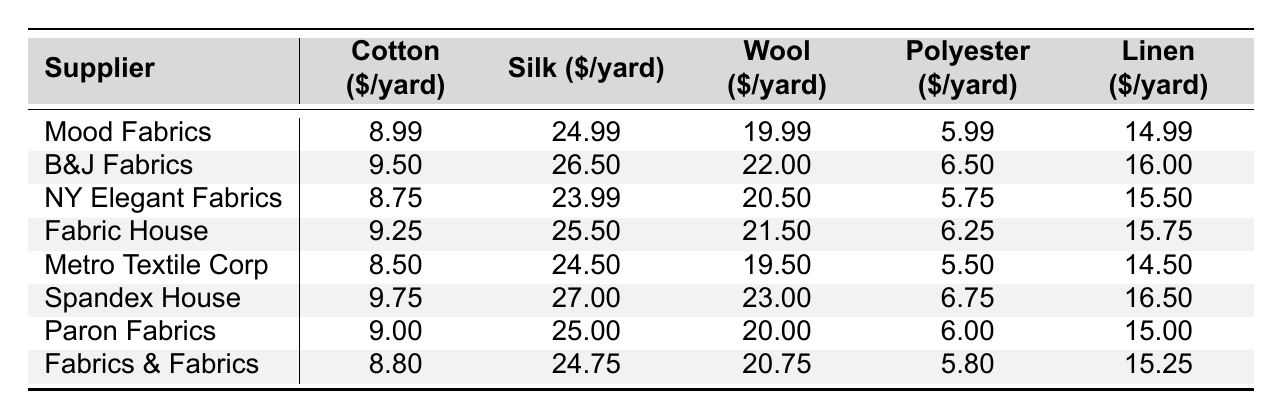What is the price of silk per yard at Mood Fabrics? According to the table, the price of silk at Mood Fabrics is directly listed as 24.99 dollars per yard.
Answer: 24.99 Which supplier offers the cheapest cotton? The table shows that the cotton price is lowest at Metro Textile Corp, where it costs 8.50 dollars per yard.
Answer: 8.50 What is the price difference between the silk at B&J Fabrics and NY Elegant Fabrics? The silk price at B&J Fabrics is 26.50 dollars and at NY Elegant Fabrics is 23.99 dollars. The difference is calculated as 26.50 - 23.99 = 2.51 dollars.
Answer: 2.51 Which supplier has the most expensive wool? Look at the wool prices across all suppliers, and you'll find that Spandex House offers the most expensive wool at 23.00 dollars per yard.
Answer: Spandex House What is the average price of polyester across all suppliers? To find the average, sum the polyester prices: (5.99 + 6.50 + 5.75 + 6.25 + 5.50 + 6.75 + 6.00 + 5.80) = 48.54 dollars. Then, divide by the number of suppliers (8) which gives 48.54 / 8 = 6.0675 dollars.
Answer: 6.07 Is the price of linen at Fabric House higher than at Mood Fabrics? Check the linen prices: Fabric House charges 15.75 dollars and Mood Fabrics charges 14.99 dollars. Since 15.75 is greater than 14.99, the answer is yes.
Answer: Yes If I want to buy all five types of fabric from the cheapest supplier, how much would it cost in total? First, identify the cheapest prices: Cotton (Metro Textile Corp - 8.50), Silk (NY Elegant Fabrics - 23.99), Wool (Metro Textile Corp - 19.50), Polyester (Metro Textile Corp - 5.50), Linen (Metro Textile Corp - 14.50). Add these values: 8.50 + 23.99 + 19.50 + 5.50 + 14.50 = 71.99 dollars.
Answer: 71.99 How much more expensive is silk at Spandex House compared to NY Elegant Fabrics? Silk at Spandex House costs 27.00 dollars and at NY Elegant Fabrics, it costs 23.99 dollars. The difference is 27.00 - 23.99 = 3.01 dollars.
Answer: 3.01 Which supplier has the lowest total cost for buying one yard of each fabric type? Calculate the total costs: Mood Fabrics (8.99 + 24.99 + 19.99 + 5.99 + 14.99 = 74.95), B&J Fabrics (9.50 + 26.50 + 22.00 + 6.50 + 16.00 = 80.50), NY Elegant Fabrics (8.75 + 23.99 + 20.50 + 5.75 + 15.50 = 74.49), and so on. The lowest total found will determine the answer. The cheapest is NY Elegant Fabrics at 74.49 dollars.
Answer: NY Elegant Fabrics What is the maximum price for linen among all suppliers? The table lists the linen prices as follows: 14.99, 16.00, 15.50, 15.75, 14.50, 16.50, 15.00, and 15.25. The maximum is 16.50 dollars from Spandex House.
Answer: 16.50 